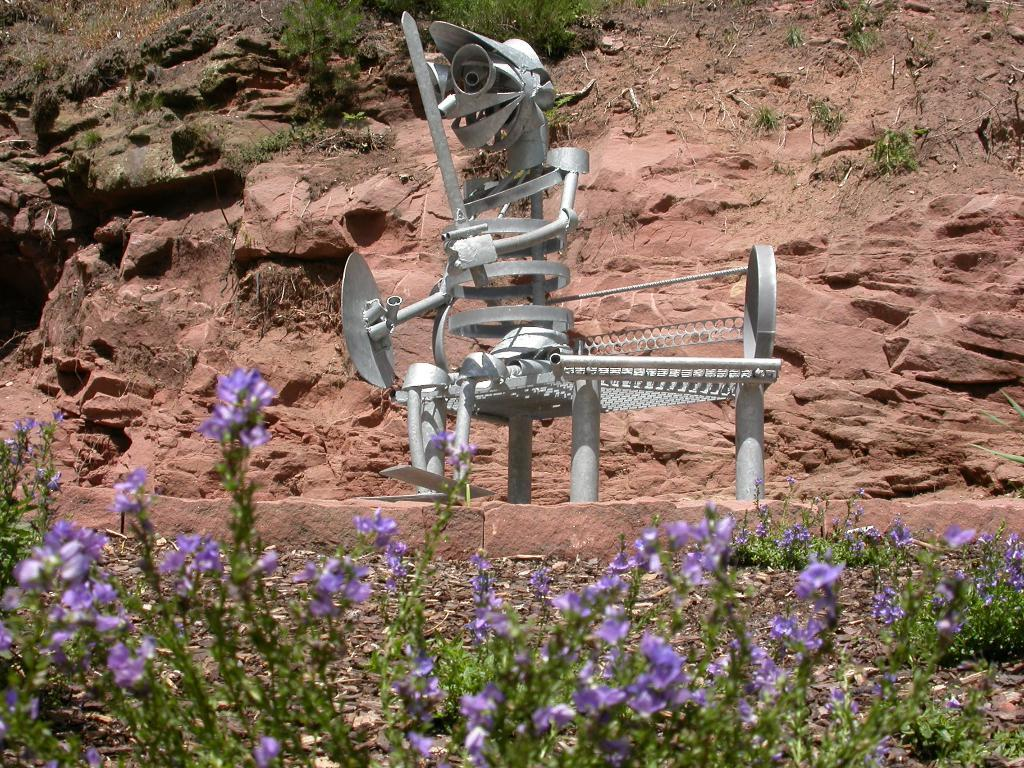What is the main subject in the center of the image? There is a depiction of a person in the center of the image. What type of plants can be seen at the bottom of the image? There are flower plants at the bottom of the image. What natural feature is visible in the background of the image? There is a mountain visible in the background of the image. Where can the toothpaste be found in the image? There is no toothpaste present in the image. 